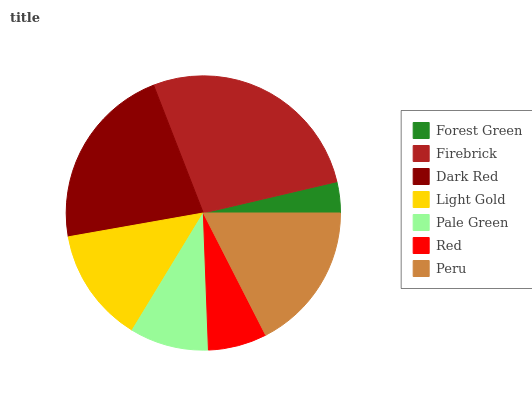Is Forest Green the minimum?
Answer yes or no. Yes. Is Firebrick the maximum?
Answer yes or no. Yes. Is Dark Red the minimum?
Answer yes or no. No. Is Dark Red the maximum?
Answer yes or no. No. Is Firebrick greater than Dark Red?
Answer yes or no. Yes. Is Dark Red less than Firebrick?
Answer yes or no. Yes. Is Dark Red greater than Firebrick?
Answer yes or no. No. Is Firebrick less than Dark Red?
Answer yes or no. No. Is Light Gold the high median?
Answer yes or no. Yes. Is Light Gold the low median?
Answer yes or no. Yes. Is Peru the high median?
Answer yes or no. No. Is Pale Green the low median?
Answer yes or no. No. 